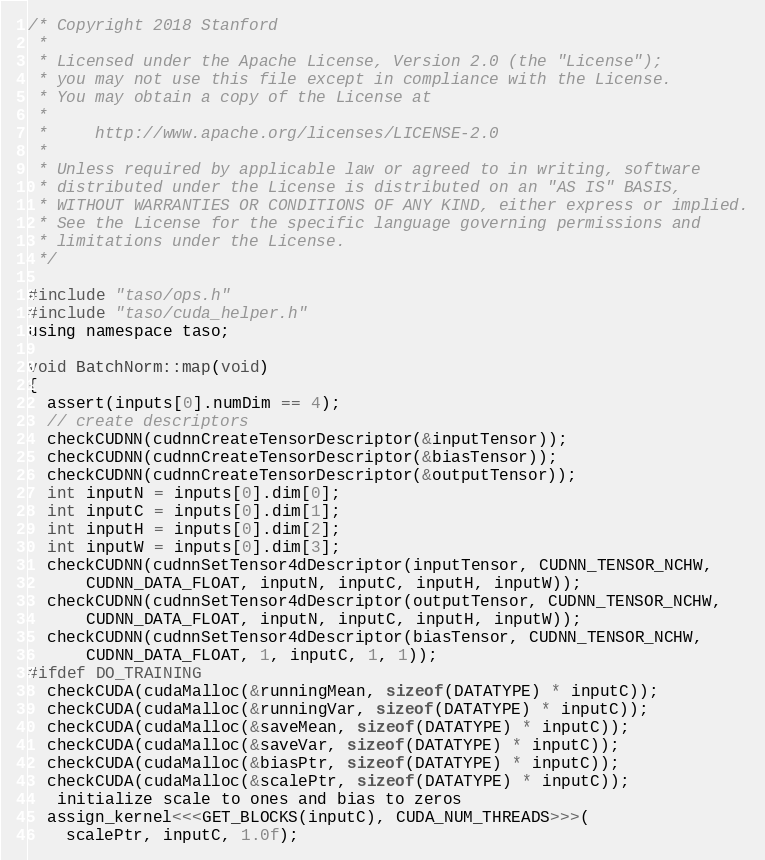Convert code to text. <code><loc_0><loc_0><loc_500><loc_500><_Cuda_>/* Copyright 2018 Stanford
 *
 * Licensed under the Apache License, Version 2.0 (the "License");
 * you may not use this file except in compliance with the License.
 * You may obtain a copy of the License at
 *
 *     http://www.apache.org/licenses/LICENSE-2.0
 *
 * Unless required by applicable law or agreed to in writing, software
 * distributed under the License is distributed on an "AS IS" BASIS,
 * WITHOUT WARRANTIES OR CONDITIONS OF ANY KIND, either express or implied.
 * See the License for the specific language governing permissions and
 * limitations under the License.
 */

#include "taso/ops.h"
#include "taso/cuda_helper.h"
using namespace taso;

void BatchNorm::map(void)
{
  assert(inputs[0].numDim == 4);
  // create descriptors
  checkCUDNN(cudnnCreateTensorDescriptor(&inputTensor));
  checkCUDNN(cudnnCreateTensorDescriptor(&biasTensor));
  checkCUDNN(cudnnCreateTensorDescriptor(&outputTensor));
  int inputN = inputs[0].dim[0];
  int inputC = inputs[0].dim[1];
  int inputH = inputs[0].dim[2];
  int inputW = inputs[0].dim[3];
  checkCUDNN(cudnnSetTensor4dDescriptor(inputTensor, CUDNN_TENSOR_NCHW,
      CUDNN_DATA_FLOAT, inputN, inputC, inputH, inputW));
  checkCUDNN(cudnnSetTensor4dDescriptor(outputTensor, CUDNN_TENSOR_NCHW,
      CUDNN_DATA_FLOAT, inputN, inputC, inputH, inputW));
  checkCUDNN(cudnnSetTensor4dDescriptor(biasTensor, CUDNN_TENSOR_NCHW,
      CUDNN_DATA_FLOAT, 1, inputC, 1, 1));
#ifdef DO_TRAINING
  checkCUDA(cudaMalloc(&runningMean, sizeof(DATATYPE) * inputC));
  checkCUDA(cudaMalloc(&runningVar, sizeof(DATATYPE) * inputC));
  checkCUDA(cudaMalloc(&saveMean, sizeof(DATATYPE) * inputC));
  checkCUDA(cudaMalloc(&saveVar, sizeof(DATATYPE) * inputC));
  checkCUDA(cudaMalloc(&biasPtr, sizeof(DATATYPE) * inputC));
  checkCUDA(cudaMalloc(&scalePtr, sizeof(DATATYPE) * inputC));
   initialize scale to ones and bias to zeros
  assign_kernel<<<GET_BLOCKS(inputC), CUDA_NUM_THREADS>>>(
    scalePtr, inputC, 1.0f);</code> 